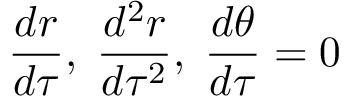<formula> <loc_0><loc_0><loc_500><loc_500>{ \frac { d r } { d \tau } } , \, { \frac { d ^ { 2 } r } { d \tau ^ { 2 } } } , \, { \frac { d \theta } { d \tau } } = 0</formula> 